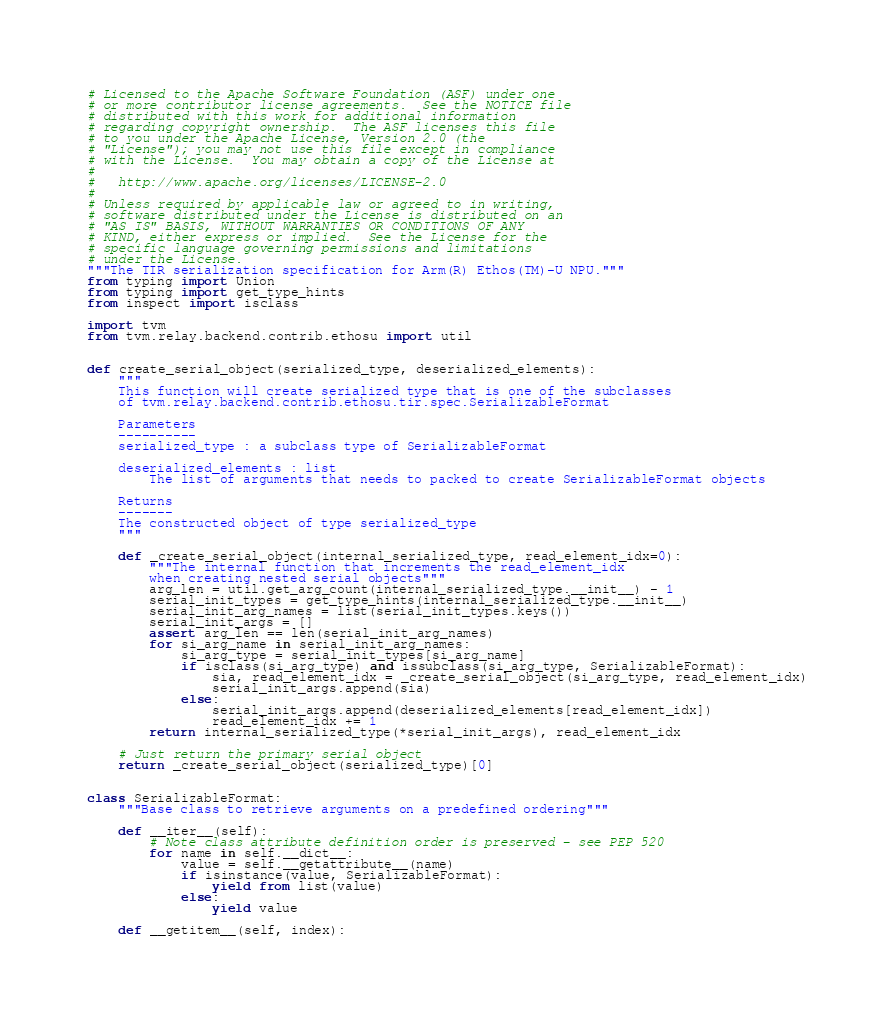Convert code to text. <code><loc_0><loc_0><loc_500><loc_500><_Python_># Licensed to the Apache Software Foundation (ASF) under one
# or more contributor license agreements.  See the NOTICE file
# distributed with this work for additional information
# regarding copyright ownership.  The ASF licenses this file
# to you under the Apache License, Version 2.0 (the
# "License"); you may not use this file except in compliance
# with the License.  You may obtain a copy of the License at
#
#   http://www.apache.org/licenses/LICENSE-2.0
#
# Unless required by applicable law or agreed to in writing,
# software distributed under the License is distributed on an
# "AS IS" BASIS, WITHOUT WARRANTIES OR CONDITIONS OF ANY
# KIND, either express or implied.  See the License for the
# specific language governing permissions and limitations
# under the License.
"""The TIR serialization specification for Arm(R) Ethos(TM)-U NPU."""
from typing import Union
from typing import get_type_hints
from inspect import isclass

import tvm
from tvm.relay.backend.contrib.ethosu import util


def create_serial_object(serialized_type, deserialized_elements):
    """
    This function will create serialized type that is one of the subclasses
    of tvm.relay.backend.contrib.ethosu.tir.spec.SerializableFormat

    Parameters
    ----------
    serialized_type : a subclass type of SerializableFormat

    deserialized_elements : list
        The list of arguments that needs to packed to create SerializableFormat objects

    Returns
    -------
    The constructed object of type serialized_type
    """

    def _create_serial_object(internal_serialized_type, read_element_idx=0):
        """The internal function that increments the read_element_idx
        when creating nested serial objects"""
        arg_len = util.get_arg_count(internal_serialized_type.__init__) - 1
        serial_init_types = get_type_hints(internal_serialized_type.__init__)
        serial_init_arg_names = list(serial_init_types.keys())
        serial_init_args = []
        assert arg_len == len(serial_init_arg_names)
        for si_arg_name in serial_init_arg_names:
            si_arg_type = serial_init_types[si_arg_name]
            if isclass(si_arg_type) and issubclass(si_arg_type, SerializableFormat):
                sia, read_element_idx = _create_serial_object(si_arg_type, read_element_idx)
                serial_init_args.append(sia)
            else:
                serial_init_args.append(deserialized_elements[read_element_idx])
                read_element_idx += 1
        return internal_serialized_type(*serial_init_args), read_element_idx

    # Just return the primary serial object
    return _create_serial_object(serialized_type)[0]


class SerializableFormat:
    """Base class to retrieve arguments on a predefined ordering"""

    def __iter__(self):
        # Note class attribute definition order is preserved - see PEP 520
        for name in self.__dict__:
            value = self.__getattribute__(name)
            if isinstance(value, SerializableFormat):
                yield from list(value)
            else:
                yield value

    def __getitem__(self, index):</code> 